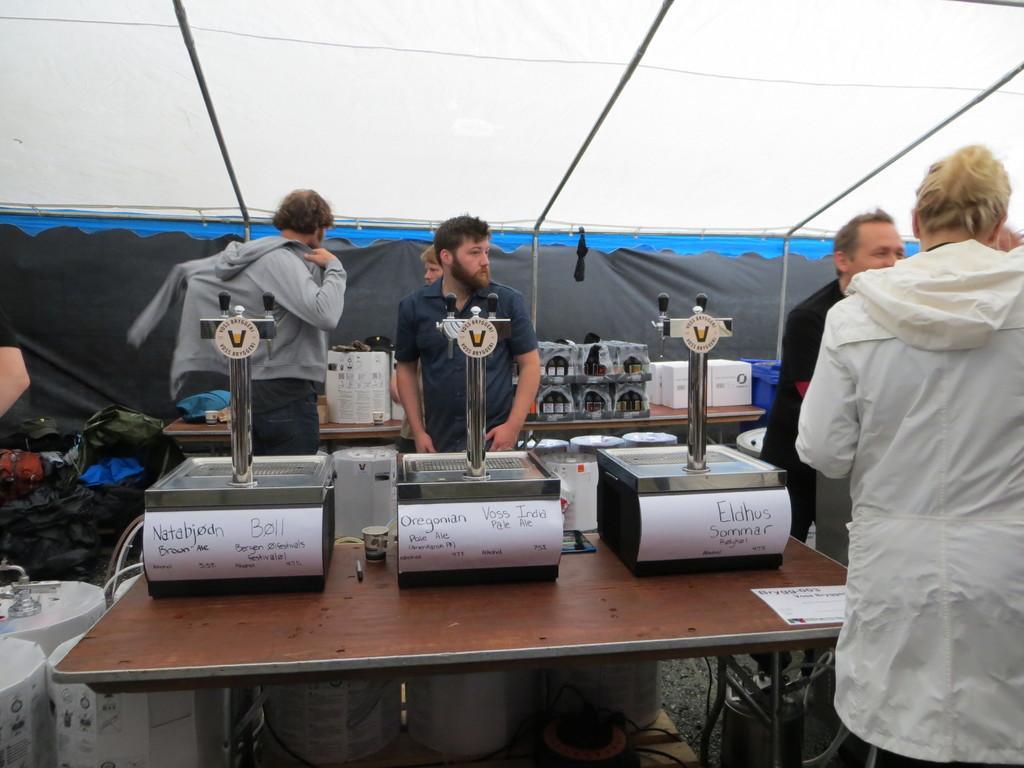How would you summarize this image in a sentence or two? The picture is under a tent. There are few people standing. There are some machines on the table. In the background there are few other machines and carton on the table. 